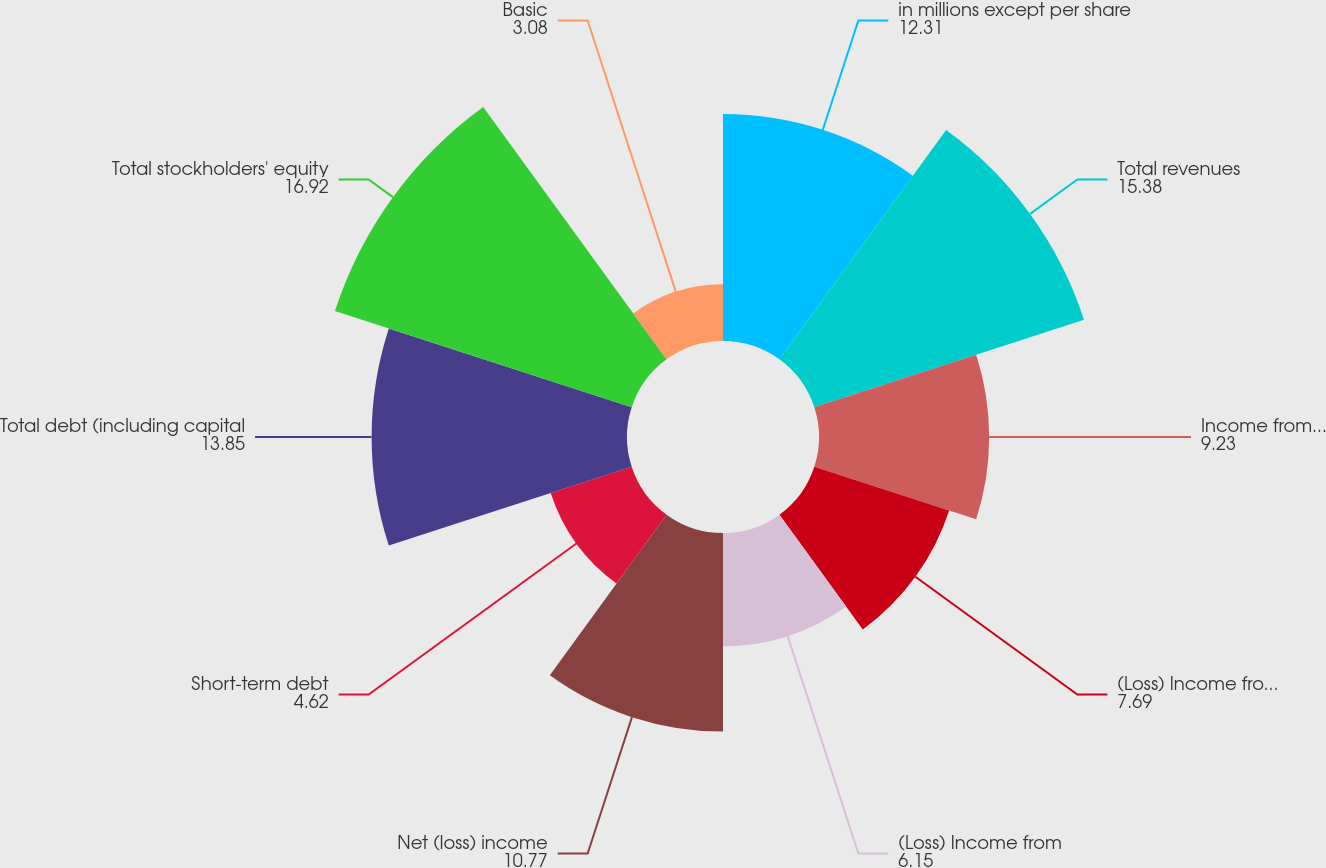Convert chart to OTSL. <chart><loc_0><loc_0><loc_500><loc_500><pie_chart><fcel>in millions except per share<fcel>Total revenues<fcel>Income from continuing<fcel>(Loss) Income from continuing<fcel>(Loss) Income from<fcel>Net (loss) income<fcel>Short-term debt<fcel>Total debt (including capital<fcel>Total stockholders' equity<fcel>Basic<nl><fcel>12.31%<fcel>15.38%<fcel>9.23%<fcel>7.69%<fcel>6.15%<fcel>10.77%<fcel>4.62%<fcel>13.85%<fcel>16.92%<fcel>3.08%<nl></chart> 